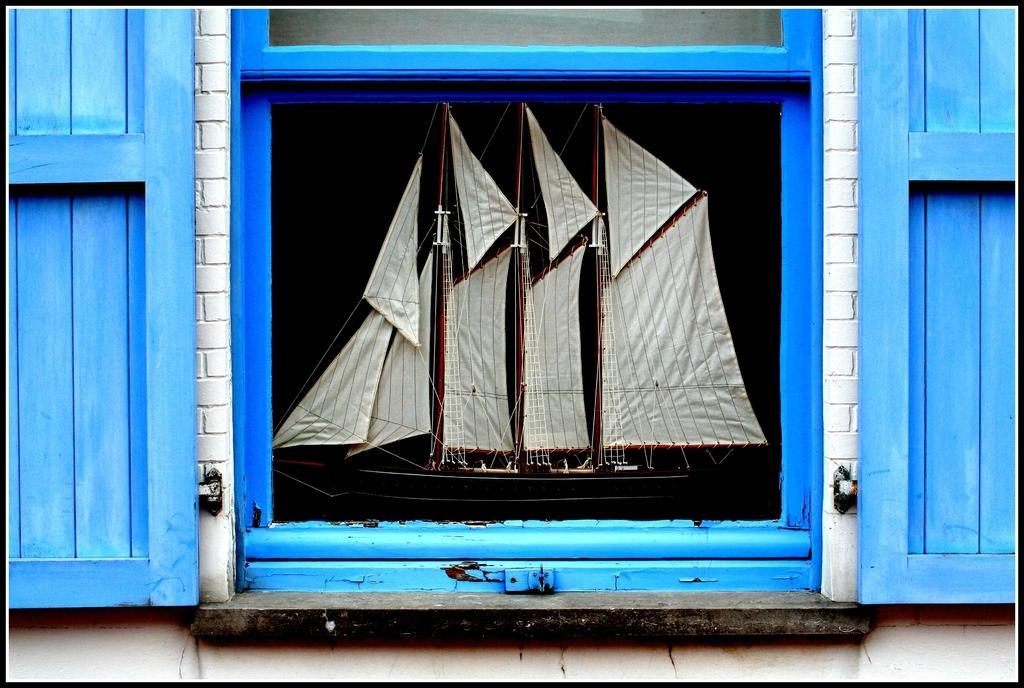Could you give a brief overview of what you see in this image? In this image I can see a window and through the window I can see a boat. I can also see blue colour doors of the window. 